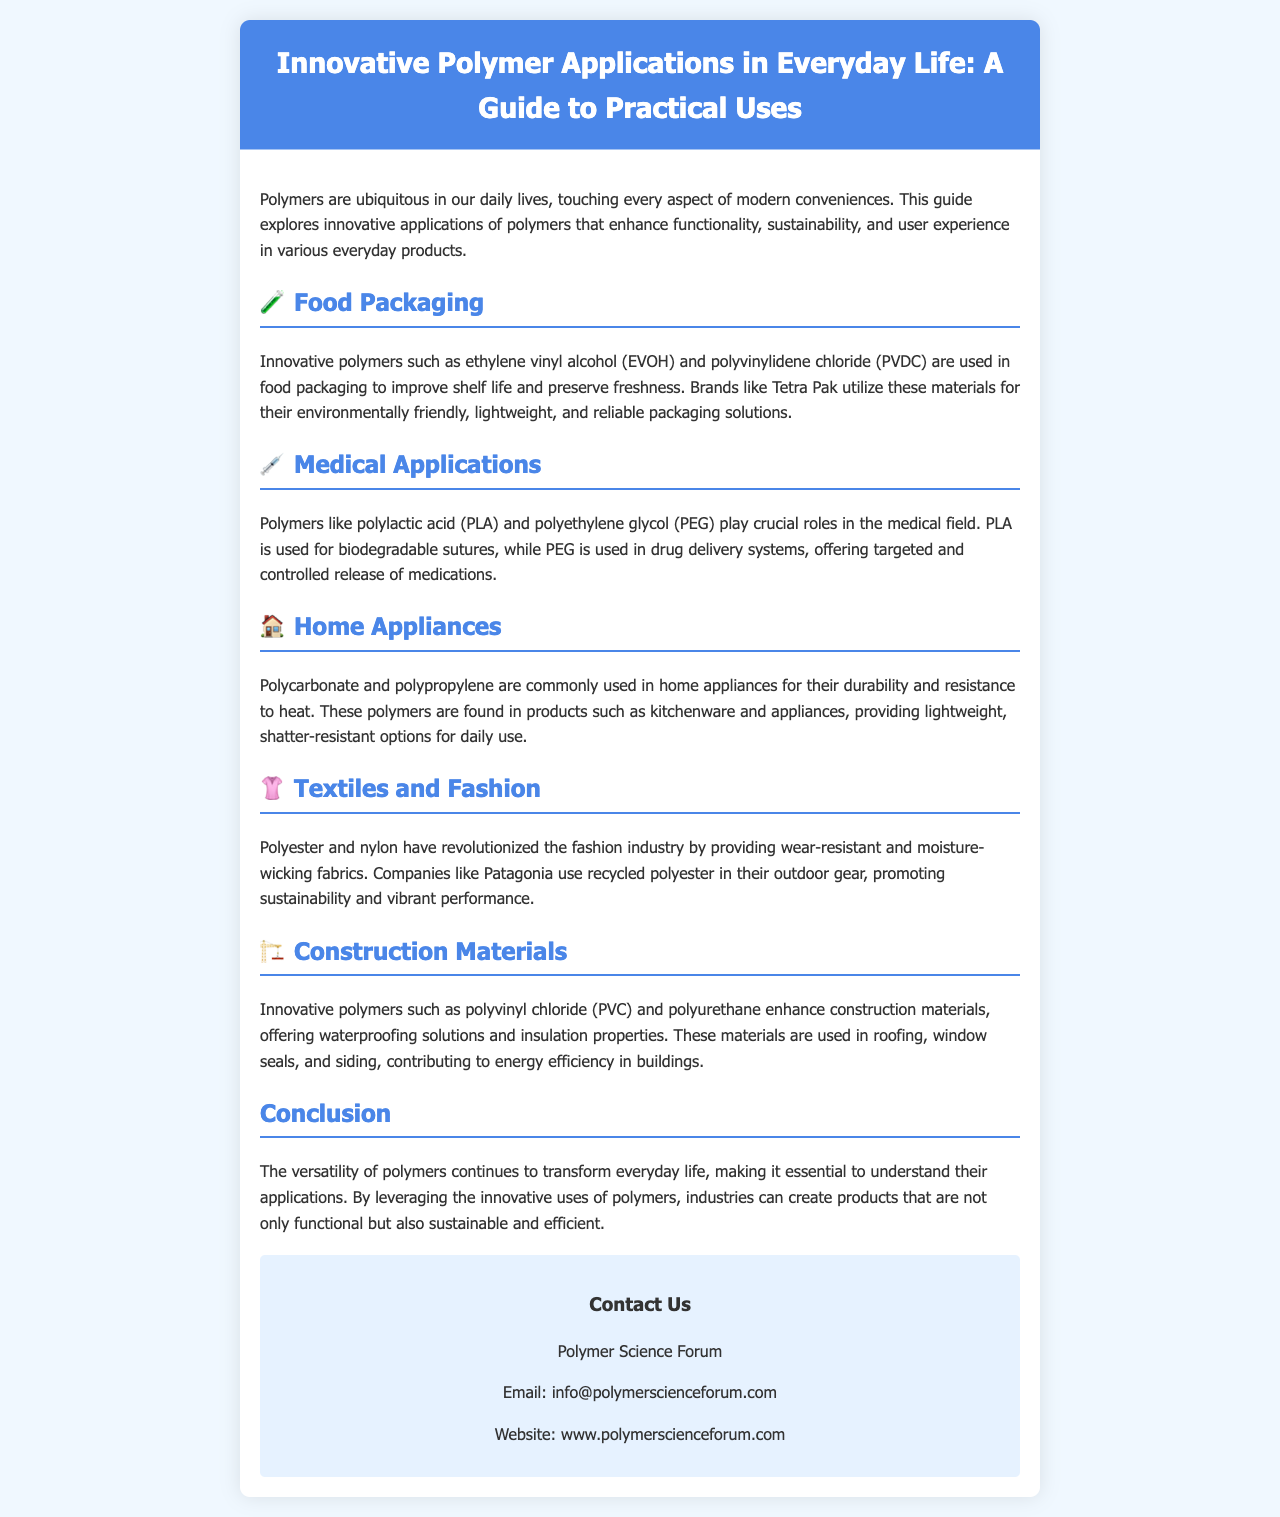what is the title of the brochure? The title of the brochure is mentioned at the top of the document.
Answer: Innovative Polymer Applications in Everyday Life: A Guide to Practical Uses which polymer is used in food packaging? The brochure specifies innovative polymers used in food packaging.
Answer: ethylene vinyl alcohol (EVOH) and polyvinylidene chloride (PVDC) what is PLA used for in the medical field? The document explains the application of PLA in medical products.
Answer: biodegradable sutures name one polymer used in home appliances. The document lists common polymers found in home appliances.
Answer: polycarbonate which company uses recycled polyester in their outdoor gear? The brochure references companies focusing on sustainability in textiles.
Answer: Patagonia what advantage do PVC and polyurethane offer in construction? The brochure outlines the benefits of certain polymers in construction materials.
Answer: waterproofing solutions and insulation properties how many sections are dedicated to polymer applications in the brochure? The document lists the various sections concerning polymer applications.
Answer: five what is the overall conclusion about the versatility of polymers? The conclusion section summarizes the implications of polymer usage in daily life.
Answer: essential to understand their applications 